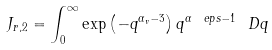Convert formula to latex. <formula><loc_0><loc_0><loc_500><loc_500>J _ { r , 2 } = \int _ { 0 } ^ { \infty } \exp \left ( - q ^ { \alpha _ { v } - 3 } \right ) q ^ { \alpha _ { \ } e p s - 1 } \ D { q }</formula> 